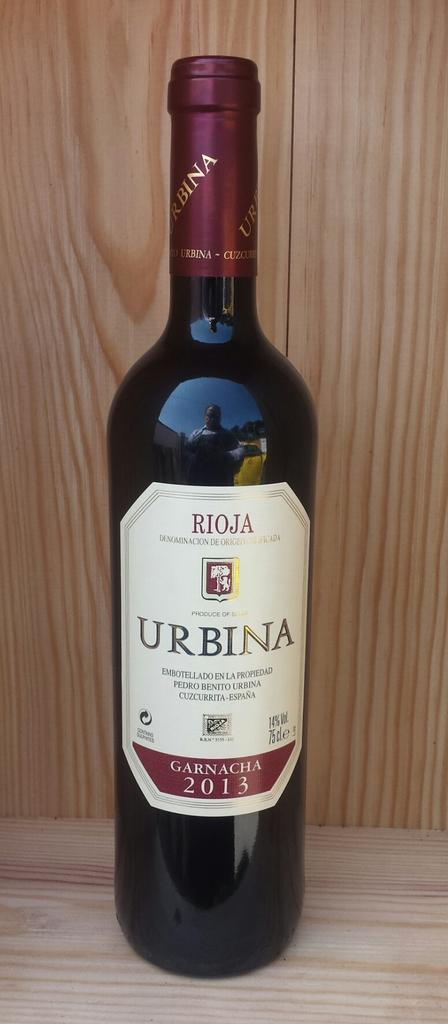<image>
Relay a brief, clear account of the picture shown. A bottle of wine with Urbina on the label. 